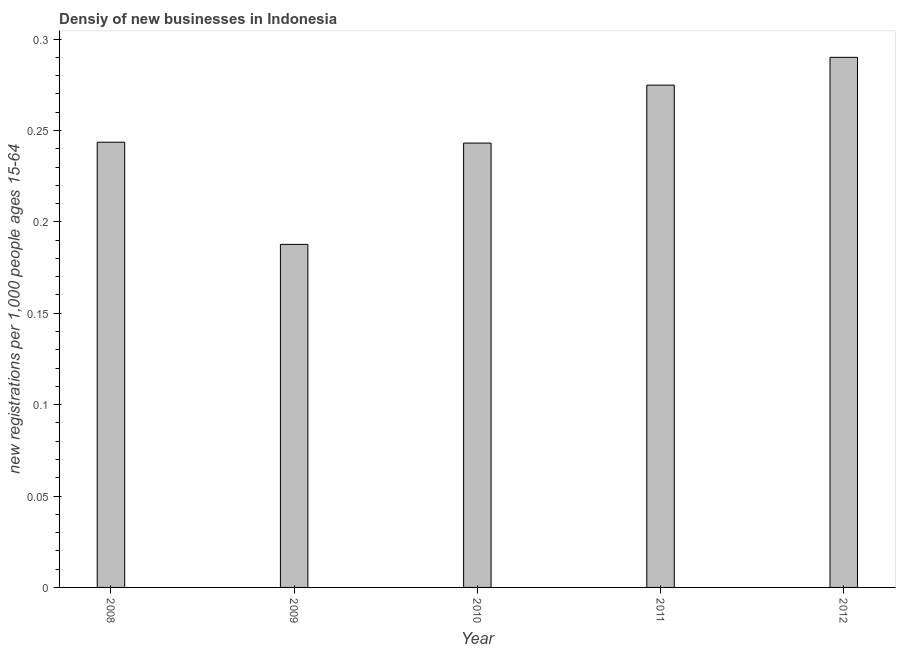Does the graph contain any zero values?
Give a very brief answer. No. Does the graph contain grids?
Keep it short and to the point. No. What is the title of the graph?
Give a very brief answer. Densiy of new businesses in Indonesia. What is the label or title of the X-axis?
Your answer should be compact. Year. What is the label or title of the Y-axis?
Keep it short and to the point. New registrations per 1,0 people ages 15-64. What is the density of new business in 2009?
Keep it short and to the point. 0.19. Across all years, what is the maximum density of new business?
Your answer should be very brief. 0.29. Across all years, what is the minimum density of new business?
Make the answer very short. 0.19. What is the sum of the density of new business?
Your response must be concise. 1.24. What is the difference between the density of new business in 2011 and 2012?
Give a very brief answer. -0.01. What is the average density of new business per year?
Offer a very short reply. 0.25. What is the median density of new business?
Offer a terse response. 0.24. In how many years, is the density of new business greater than 0.16 ?
Keep it short and to the point. 5. Do a majority of the years between 2008 and 2009 (inclusive) have density of new business greater than 0.29 ?
Provide a succinct answer. No. What is the ratio of the density of new business in 2008 to that in 2011?
Keep it short and to the point. 0.89. Is the density of new business in 2009 less than that in 2012?
Your response must be concise. Yes. Is the difference between the density of new business in 2008 and 2010 greater than the difference between any two years?
Offer a very short reply. No. What is the difference between the highest and the second highest density of new business?
Make the answer very short. 0.01. How many bars are there?
Your answer should be compact. 5. Are all the bars in the graph horizontal?
Your response must be concise. No. What is the difference between two consecutive major ticks on the Y-axis?
Your answer should be compact. 0.05. What is the new registrations per 1,000 people ages 15-64 in 2008?
Provide a succinct answer. 0.24. What is the new registrations per 1,000 people ages 15-64 of 2009?
Your answer should be very brief. 0.19. What is the new registrations per 1,000 people ages 15-64 of 2010?
Ensure brevity in your answer.  0.24. What is the new registrations per 1,000 people ages 15-64 of 2011?
Give a very brief answer. 0.27. What is the new registrations per 1,000 people ages 15-64 in 2012?
Provide a short and direct response. 0.29. What is the difference between the new registrations per 1,000 people ages 15-64 in 2008 and 2009?
Provide a short and direct response. 0.06. What is the difference between the new registrations per 1,000 people ages 15-64 in 2008 and 2010?
Provide a succinct answer. 0. What is the difference between the new registrations per 1,000 people ages 15-64 in 2008 and 2011?
Make the answer very short. -0.03. What is the difference between the new registrations per 1,000 people ages 15-64 in 2008 and 2012?
Your response must be concise. -0.05. What is the difference between the new registrations per 1,000 people ages 15-64 in 2009 and 2010?
Give a very brief answer. -0.06. What is the difference between the new registrations per 1,000 people ages 15-64 in 2009 and 2011?
Provide a short and direct response. -0.09. What is the difference between the new registrations per 1,000 people ages 15-64 in 2009 and 2012?
Ensure brevity in your answer.  -0.1. What is the difference between the new registrations per 1,000 people ages 15-64 in 2010 and 2011?
Your response must be concise. -0.03. What is the difference between the new registrations per 1,000 people ages 15-64 in 2010 and 2012?
Offer a very short reply. -0.05. What is the difference between the new registrations per 1,000 people ages 15-64 in 2011 and 2012?
Make the answer very short. -0.02. What is the ratio of the new registrations per 1,000 people ages 15-64 in 2008 to that in 2009?
Make the answer very short. 1.3. What is the ratio of the new registrations per 1,000 people ages 15-64 in 2008 to that in 2011?
Your response must be concise. 0.89. What is the ratio of the new registrations per 1,000 people ages 15-64 in 2008 to that in 2012?
Provide a short and direct response. 0.84. What is the ratio of the new registrations per 1,000 people ages 15-64 in 2009 to that in 2010?
Offer a very short reply. 0.77. What is the ratio of the new registrations per 1,000 people ages 15-64 in 2009 to that in 2011?
Offer a very short reply. 0.68. What is the ratio of the new registrations per 1,000 people ages 15-64 in 2009 to that in 2012?
Make the answer very short. 0.65. What is the ratio of the new registrations per 1,000 people ages 15-64 in 2010 to that in 2011?
Give a very brief answer. 0.89. What is the ratio of the new registrations per 1,000 people ages 15-64 in 2010 to that in 2012?
Your response must be concise. 0.84. What is the ratio of the new registrations per 1,000 people ages 15-64 in 2011 to that in 2012?
Ensure brevity in your answer.  0.95. 